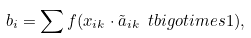Convert formula to latex. <formula><loc_0><loc_0><loc_500><loc_500>b _ { i } = \sum f ( x _ { i k } \cdot \tilde { a } _ { i k } \ t b i g o t i m e s 1 ) ,</formula> 